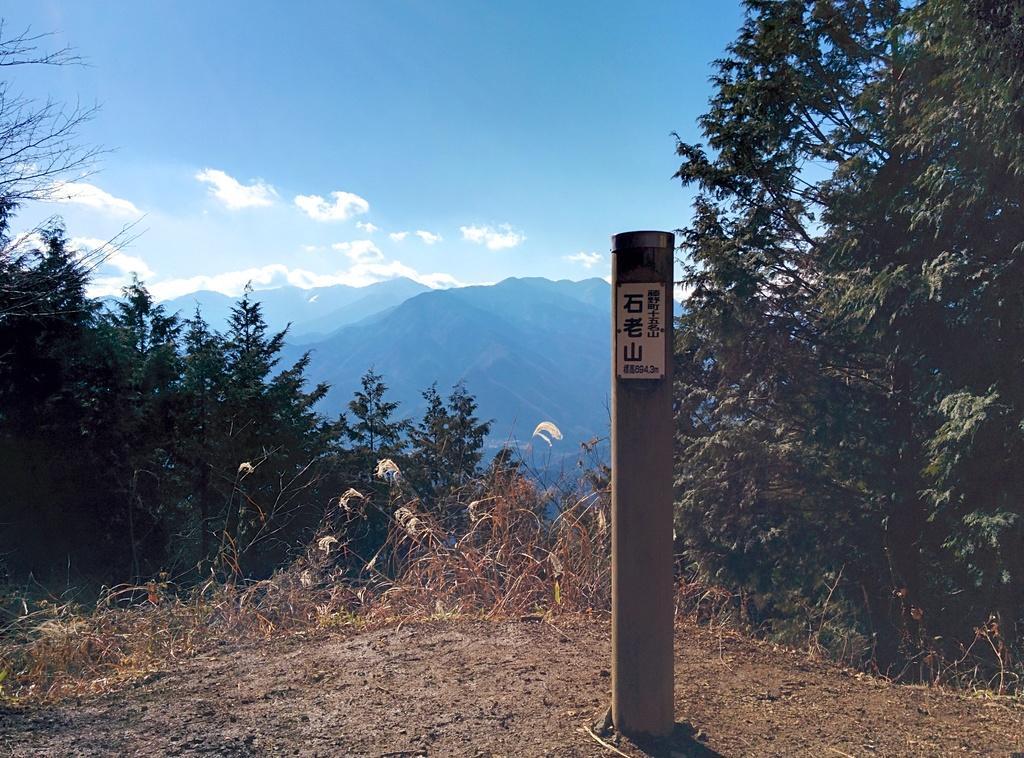Please provide a concise description of this image. In this picture I can observe a pole on the right side. I can observe some trees in this picture. In the background there are hills and some clouds in the sky. 